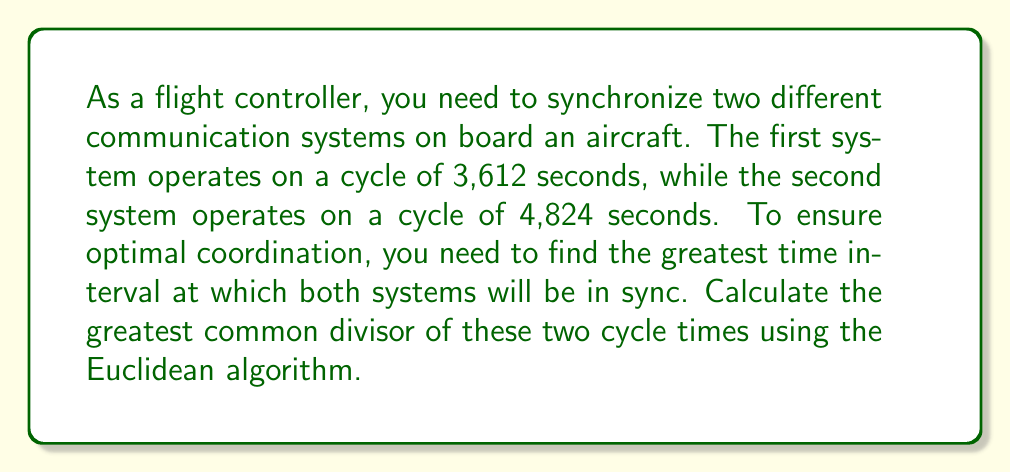Solve this math problem. Let's apply the Euclidean algorithm to find the greatest common divisor (GCD) of 3,612 and 4,824.

The Euclidean algorithm states that the GCD of two numbers $a$ and $b$ is the same as the GCD of $b$ and the remainder of $a$ divided by $b$.

Let's start:

1) First, divide 4,824 by 3,612:
   $$4,824 = 1 \times 3,612 + 1,212$$

2) Now, divide 3,612 by 1,212:
   $$3,612 = 2 \times 1,212 + 1,188$$

3) Divide 1,212 by 1,188:
   $$1,212 = 1 \times 1,188 + 24$$

4) Divide 1,188 by 24:
   $$1,188 = 49 \times 24 + 12$$

5) Divide 24 by 12:
   $$24 = 2 \times 12 + 0$$

The process stops when we get a remainder of 0. The last non-zero remainder is the GCD.

Therefore, the GCD of 3,612 and 4,824 is 12.

This means that the two communication systems will be in sync every 12 seconds, which is the greatest time interval for synchronization.
Answer: The greatest common divisor of 3,612 and 4,824 is 12 seconds. 